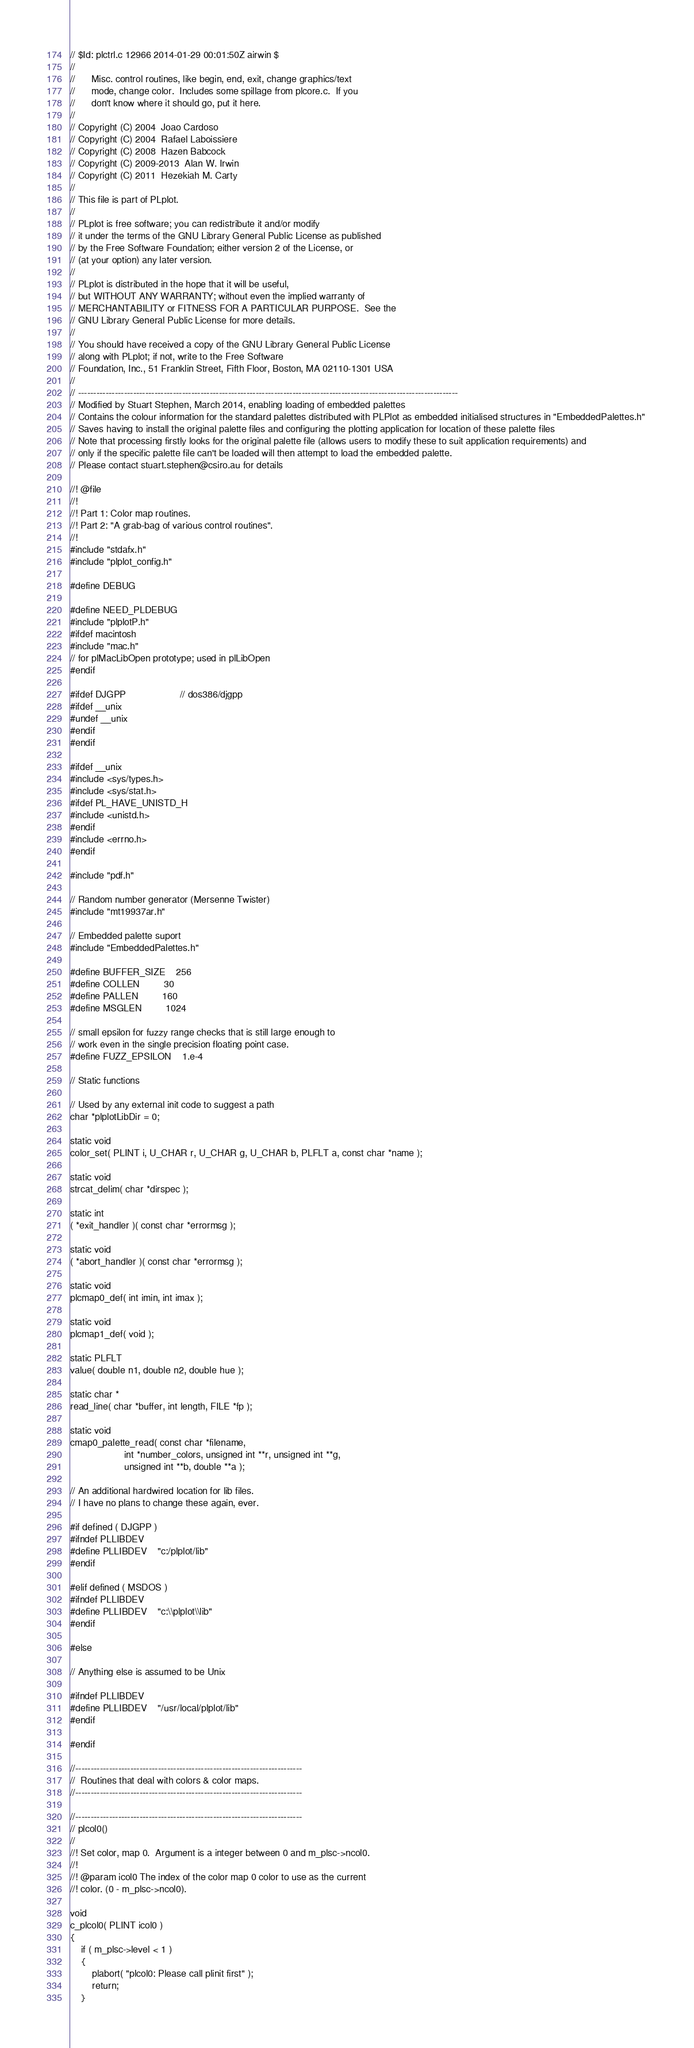Convert code to text. <code><loc_0><loc_0><loc_500><loc_500><_C++_>// $Id: plctrl.c 12966 2014-01-29 00:01:50Z airwin $
//
//      Misc. control routines, like begin, end, exit, change graphics/text
//      mode, change color.  Includes some spillage from plcore.c.  If you
//      don't know where it should go, put it here.
//
// Copyright (C) 2004  Joao Cardoso
// Copyright (C) 2004  Rafael Laboissiere
// Copyright (C) 2008  Hazen Babcock
// Copyright (C) 2009-2013  Alan W. Irwin
// Copyright (C) 2011  Hezekiah M. Carty
//
// This file is part of PLplot.
//
// PLplot is free software; you can redistribute it and/or modify
// it under the terms of the GNU Library General Public License as published
// by the Free Software Foundation; either version 2 of the License, or
// (at your option) any later version.
//
// PLplot is distributed in the hope that it will be useful,
// but WITHOUT ANY WARRANTY; without even the implied warranty of
// MERCHANTABILITY or FITNESS FOR A PARTICULAR PURPOSE.  See the
// GNU Library General Public License for more details.
//
// You should have received a copy of the GNU Library General Public License
// along with PLplot; if not, write to the Free Software
// Foundation, Inc., 51 Franklin Street, Fifth Floor, Boston, MA 02110-1301 USA
//
// ----------------------------------------------------------------------------------------------------------------------------
// Modified by Stuart Stephen, March 2014, enabling loading of embedded palettes
// Contains the colour information for the standard palettes distributed with PLPlot as embedded initialised structures in "EmbeddedPalettes.h" 
// Saves having to install the original palette files and configuring the plotting application for location of these palette files
// Note that processing firstly looks for the original palette file (allows users to modify these to suit application requirements) and
// only if the specific palette file can't be loaded will then attempt to load the embedded palette.
// Please contact stuart.stephen@csiro.au for details

//! @file
//!
//! Part 1: Color map routines.
//! Part 2: "A grab-bag of various control routines".
//!
#include "stdafx.h"
#include "plplot_config.h"

#define DEBUG

#define NEED_PLDEBUG
#include "plplotP.h"
#ifdef macintosh
#include "mac.h"
// for plMacLibOpen prototype; used in plLibOpen
#endif

#ifdef DJGPP                    // dos386/djgpp
#ifdef __unix
#undef __unix
#endif
#endif

#ifdef __unix
#include <sys/types.h>
#include <sys/stat.h>
#ifdef PL_HAVE_UNISTD_H
#include <unistd.h>
#endif
#include <errno.h>
#endif

#include "pdf.h"

// Random number generator (Mersenne Twister)
#include "mt19937ar.h"

// Embedded palette suport
#include "EmbeddedPalettes.h"

#define BUFFER_SIZE    256
#define COLLEN         30
#define PALLEN         160
#define MSGLEN         1024

// small epsilon for fuzzy range checks that is still large enough to
// work even in the single precision floating point case.
#define FUZZ_EPSILON    1.e-4

// Static functions

// Used by any external init code to suggest a path
char *plplotLibDir = 0;

static void
color_set( PLINT i, U_CHAR r, U_CHAR g, U_CHAR b, PLFLT a, const char *name );

static void
strcat_delim( char *dirspec );

static int
( *exit_handler )( const char *errormsg );

static void
( *abort_handler )( const char *errormsg );

static void
plcmap0_def( int imin, int imax );

static void
plcmap1_def( void );

static PLFLT
value( double n1, double n2, double hue );

static char *
read_line( char *buffer, int length, FILE *fp );

static void
cmap0_palette_read( const char *filename,
                    int *number_colors, unsigned int **r, unsigned int **g,
                    unsigned int **b, double **a );

// An additional hardwired location for lib files.
// I have no plans to change these again, ever.

#if defined ( DJGPP )
#ifndef PLLIBDEV
#define PLLIBDEV    "c:/plplot/lib"
#endif

#elif defined ( MSDOS )
#ifndef PLLIBDEV
#define PLLIBDEV    "c:\\plplot\\lib"
#endif

#else

// Anything else is assumed to be Unix

#ifndef PLLIBDEV
#define PLLIBDEV    "/usr/local/plplot/lib"
#endif

#endif

//--------------------------------------------------------------------------
//  Routines that deal with colors & color maps.
//--------------------------------------------------------------------------

//--------------------------------------------------------------------------
// plcol0()
//
//! Set color, map 0.  Argument is a integer between 0 and m_plsc->ncol0.
//!
//! @param icol0 The index of the color map 0 color to use as the current
//! color. (0 - m_plsc->ncol0).

void
c_plcol0( PLINT icol0 )
{
    if ( m_plsc->level < 1 )
    {
        plabort( "plcol0: Please call plinit first" );
        return;
    }</code> 